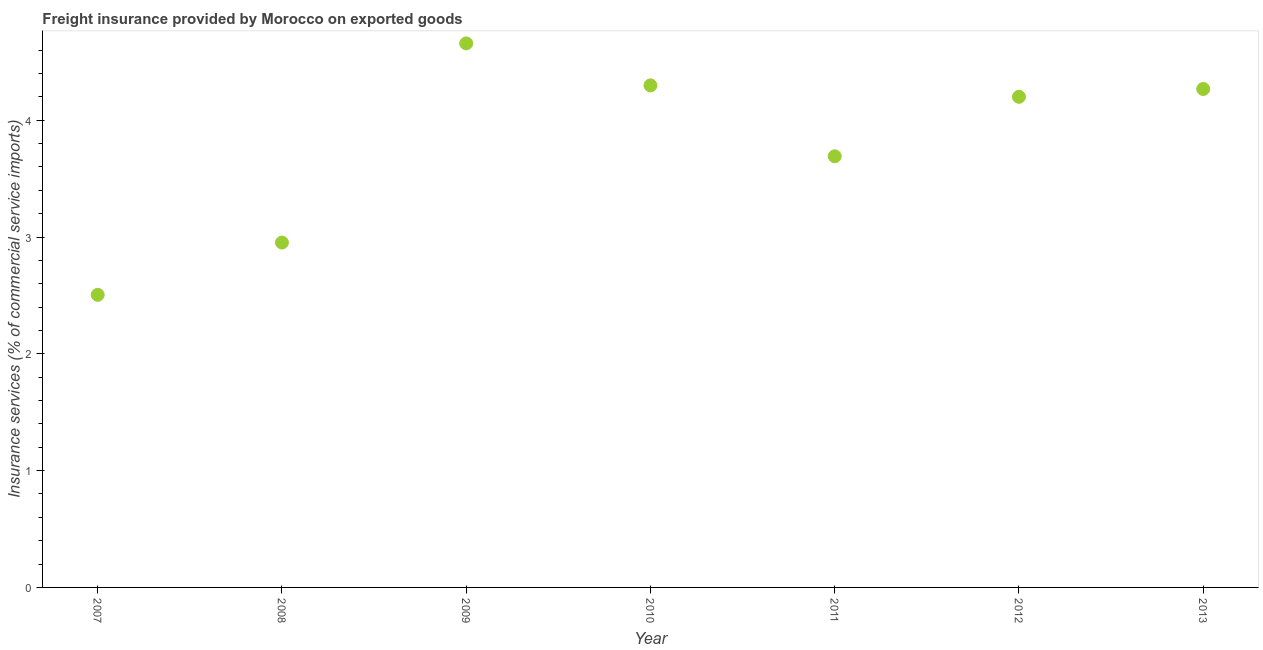What is the freight insurance in 2013?
Offer a terse response. 4.27. Across all years, what is the maximum freight insurance?
Your answer should be compact. 4.66. Across all years, what is the minimum freight insurance?
Provide a short and direct response. 2.5. What is the sum of the freight insurance?
Provide a succinct answer. 26.57. What is the difference between the freight insurance in 2008 and 2011?
Your answer should be very brief. -0.74. What is the average freight insurance per year?
Make the answer very short. 3.8. What is the median freight insurance?
Ensure brevity in your answer.  4.2. In how many years, is the freight insurance greater than 1.4 %?
Your answer should be very brief. 7. What is the ratio of the freight insurance in 2008 to that in 2009?
Offer a terse response. 0.63. What is the difference between the highest and the second highest freight insurance?
Your response must be concise. 0.36. Is the sum of the freight insurance in 2010 and 2013 greater than the maximum freight insurance across all years?
Make the answer very short. Yes. What is the difference between the highest and the lowest freight insurance?
Give a very brief answer. 2.15. Does the freight insurance monotonically increase over the years?
Keep it short and to the point. No. How many dotlines are there?
Keep it short and to the point. 1. How many years are there in the graph?
Provide a succinct answer. 7. Are the values on the major ticks of Y-axis written in scientific E-notation?
Offer a terse response. No. Does the graph contain any zero values?
Make the answer very short. No. What is the title of the graph?
Provide a short and direct response. Freight insurance provided by Morocco on exported goods . What is the label or title of the X-axis?
Your response must be concise. Year. What is the label or title of the Y-axis?
Provide a succinct answer. Insurance services (% of commercial service imports). What is the Insurance services (% of commercial service imports) in 2007?
Provide a succinct answer. 2.5. What is the Insurance services (% of commercial service imports) in 2008?
Keep it short and to the point. 2.95. What is the Insurance services (% of commercial service imports) in 2009?
Provide a succinct answer. 4.66. What is the Insurance services (% of commercial service imports) in 2010?
Keep it short and to the point. 4.3. What is the Insurance services (% of commercial service imports) in 2011?
Your answer should be compact. 3.69. What is the Insurance services (% of commercial service imports) in 2012?
Your answer should be compact. 4.2. What is the Insurance services (% of commercial service imports) in 2013?
Your answer should be very brief. 4.27. What is the difference between the Insurance services (% of commercial service imports) in 2007 and 2008?
Give a very brief answer. -0.45. What is the difference between the Insurance services (% of commercial service imports) in 2007 and 2009?
Make the answer very short. -2.15. What is the difference between the Insurance services (% of commercial service imports) in 2007 and 2010?
Give a very brief answer. -1.79. What is the difference between the Insurance services (% of commercial service imports) in 2007 and 2011?
Give a very brief answer. -1.19. What is the difference between the Insurance services (% of commercial service imports) in 2007 and 2012?
Give a very brief answer. -1.7. What is the difference between the Insurance services (% of commercial service imports) in 2007 and 2013?
Provide a succinct answer. -1.76. What is the difference between the Insurance services (% of commercial service imports) in 2008 and 2009?
Offer a very short reply. -1.71. What is the difference between the Insurance services (% of commercial service imports) in 2008 and 2010?
Ensure brevity in your answer.  -1.35. What is the difference between the Insurance services (% of commercial service imports) in 2008 and 2011?
Keep it short and to the point. -0.74. What is the difference between the Insurance services (% of commercial service imports) in 2008 and 2012?
Your answer should be very brief. -1.25. What is the difference between the Insurance services (% of commercial service imports) in 2008 and 2013?
Ensure brevity in your answer.  -1.31. What is the difference between the Insurance services (% of commercial service imports) in 2009 and 2010?
Your answer should be very brief. 0.36. What is the difference between the Insurance services (% of commercial service imports) in 2009 and 2011?
Keep it short and to the point. 0.97. What is the difference between the Insurance services (% of commercial service imports) in 2009 and 2012?
Make the answer very short. 0.46. What is the difference between the Insurance services (% of commercial service imports) in 2009 and 2013?
Offer a very short reply. 0.39. What is the difference between the Insurance services (% of commercial service imports) in 2010 and 2011?
Offer a terse response. 0.61. What is the difference between the Insurance services (% of commercial service imports) in 2010 and 2012?
Offer a very short reply. 0.1. What is the difference between the Insurance services (% of commercial service imports) in 2010 and 2013?
Offer a terse response. 0.03. What is the difference between the Insurance services (% of commercial service imports) in 2011 and 2012?
Your answer should be very brief. -0.51. What is the difference between the Insurance services (% of commercial service imports) in 2011 and 2013?
Ensure brevity in your answer.  -0.58. What is the difference between the Insurance services (% of commercial service imports) in 2012 and 2013?
Your answer should be very brief. -0.07. What is the ratio of the Insurance services (% of commercial service imports) in 2007 to that in 2008?
Make the answer very short. 0.85. What is the ratio of the Insurance services (% of commercial service imports) in 2007 to that in 2009?
Your answer should be compact. 0.54. What is the ratio of the Insurance services (% of commercial service imports) in 2007 to that in 2010?
Your answer should be very brief. 0.58. What is the ratio of the Insurance services (% of commercial service imports) in 2007 to that in 2011?
Your answer should be very brief. 0.68. What is the ratio of the Insurance services (% of commercial service imports) in 2007 to that in 2012?
Provide a short and direct response. 0.6. What is the ratio of the Insurance services (% of commercial service imports) in 2007 to that in 2013?
Make the answer very short. 0.59. What is the ratio of the Insurance services (% of commercial service imports) in 2008 to that in 2009?
Your response must be concise. 0.63. What is the ratio of the Insurance services (% of commercial service imports) in 2008 to that in 2010?
Your answer should be compact. 0.69. What is the ratio of the Insurance services (% of commercial service imports) in 2008 to that in 2011?
Ensure brevity in your answer.  0.8. What is the ratio of the Insurance services (% of commercial service imports) in 2008 to that in 2012?
Offer a terse response. 0.7. What is the ratio of the Insurance services (% of commercial service imports) in 2008 to that in 2013?
Keep it short and to the point. 0.69. What is the ratio of the Insurance services (% of commercial service imports) in 2009 to that in 2010?
Offer a very short reply. 1.08. What is the ratio of the Insurance services (% of commercial service imports) in 2009 to that in 2011?
Offer a very short reply. 1.26. What is the ratio of the Insurance services (% of commercial service imports) in 2009 to that in 2012?
Make the answer very short. 1.11. What is the ratio of the Insurance services (% of commercial service imports) in 2009 to that in 2013?
Your answer should be very brief. 1.09. What is the ratio of the Insurance services (% of commercial service imports) in 2010 to that in 2011?
Give a very brief answer. 1.16. What is the ratio of the Insurance services (% of commercial service imports) in 2010 to that in 2012?
Offer a very short reply. 1.02. What is the ratio of the Insurance services (% of commercial service imports) in 2010 to that in 2013?
Give a very brief answer. 1.01. What is the ratio of the Insurance services (% of commercial service imports) in 2011 to that in 2012?
Offer a terse response. 0.88. What is the ratio of the Insurance services (% of commercial service imports) in 2011 to that in 2013?
Your answer should be very brief. 0.86. 